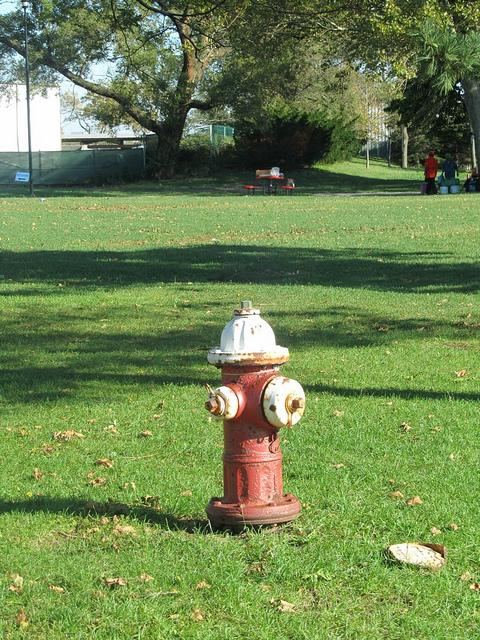Where is the fire hydrant located? Please explain your reasoning. park. There is a lot of grass, but it is taken care of.  you can see people enjoying their day. 